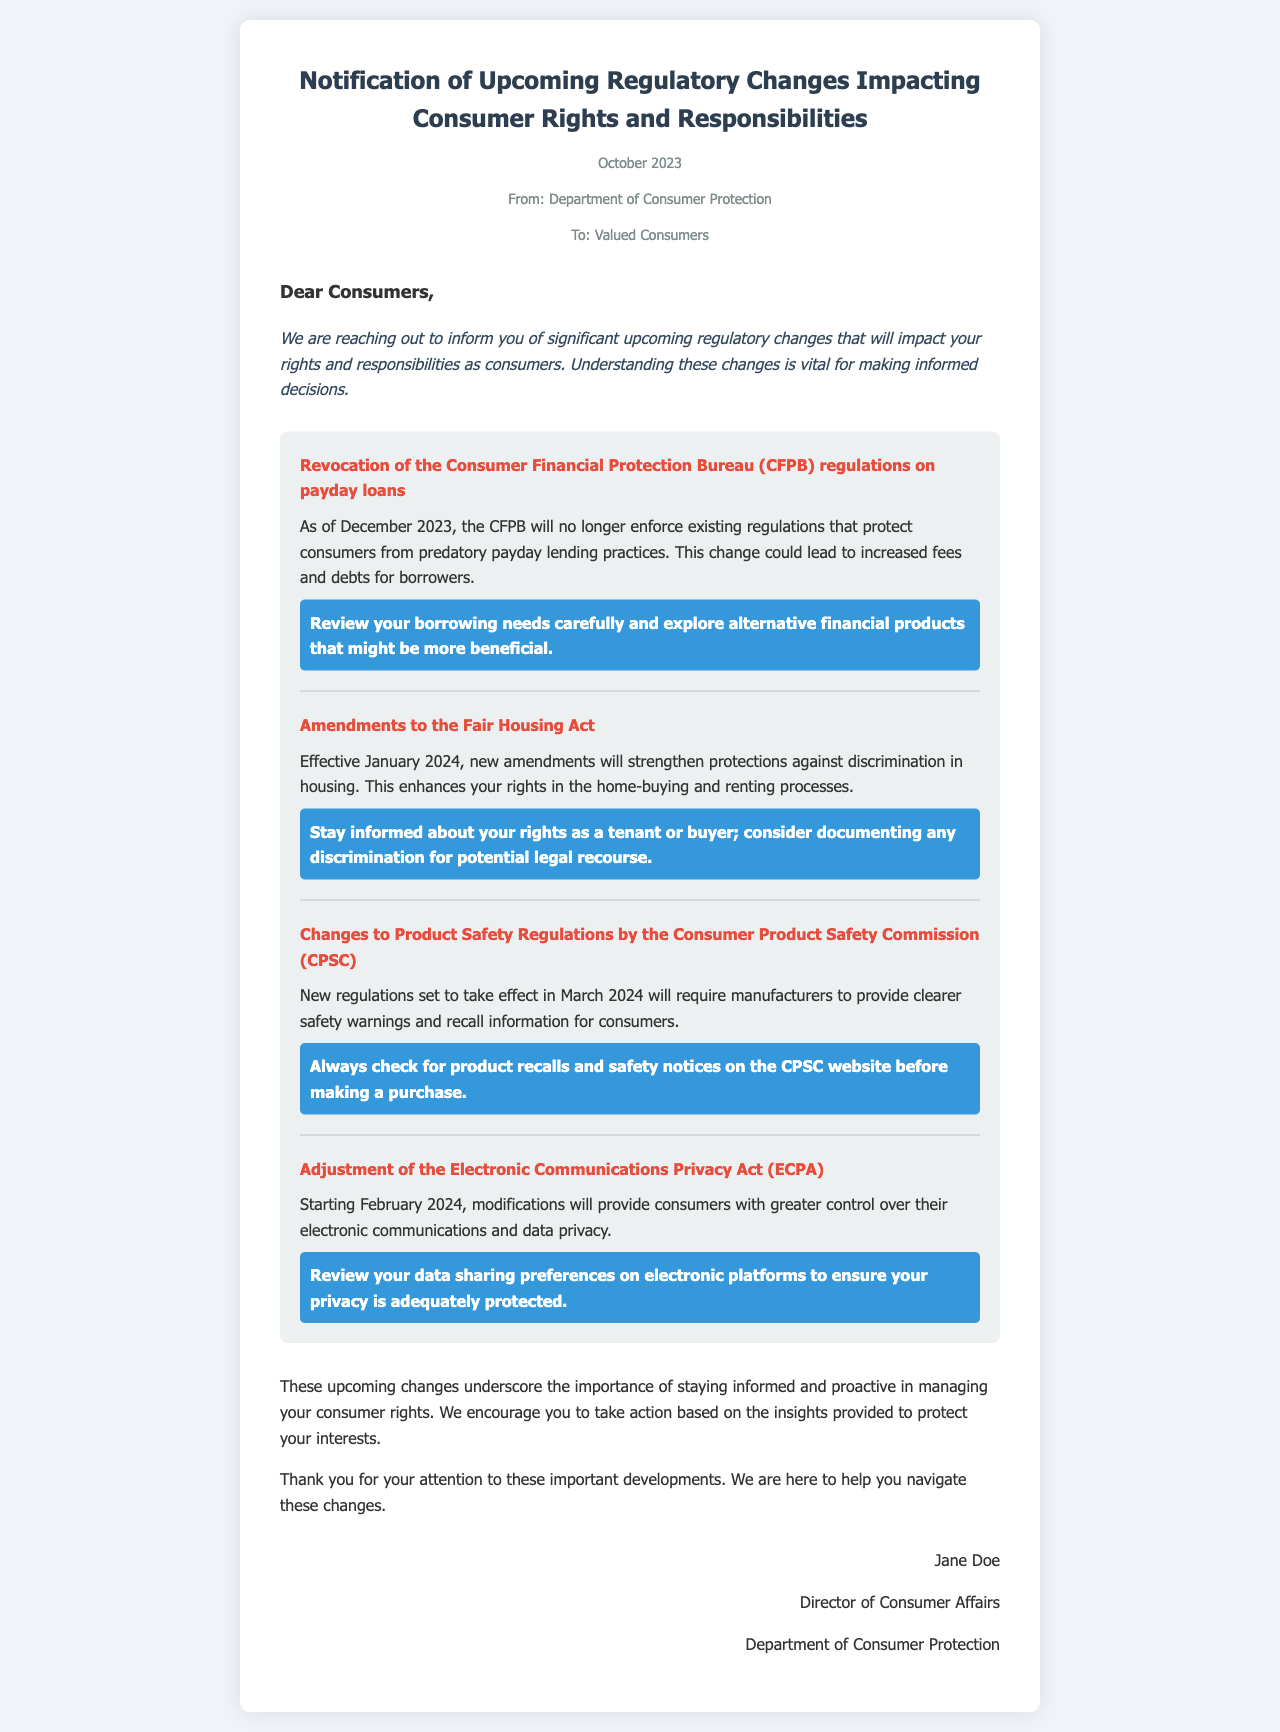What is the date of the notification? The notification is dated October 2023, as mentioned in the document details.
Answer: October 2023 Who is the sender of the letter? The sender of the letter is identified in the document as the Department of Consumer Protection.
Answer: Department of Consumer Protection What regulation is being revoked as of December 2023? The regulation being revoked is the Consumer Financial Protection Bureau (CFPB) regulations on payday loans.
Answer: CFPB regulations on payday loans What is the effective date of the amendments to the Fair Housing Act? The effective date for the amendments to the Fair Housing Act is stated as January 2024 in the document.
Answer: January 2024 What must consumers do according to the actionable insight for payday loans? Consumers are advised to review their borrowing needs carefully and explore alternative financial products.
Answer: Review your borrowing needs carefully What do the new regulations by the CPSC require manufacturers to provide? The new regulations require manufacturers to provide clearer safety warnings and recall information.
Answer: Clearer safety warnings and recall information When will the changes to the Electronic Communications Privacy Act take effect? The changes to the Electronic Communications Privacy Act will take effect starting in February 2024.
Answer: February 2024 What is the role of Jane Doe as per the letter? Jane Doe is identified as the Director of Consumer Affairs in the document.
Answer: Director of Consumer Affairs What is the main purpose of the letter? The main purpose of the letter is to inform consumers about significant upcoming regulatory changes impacting their rights and responsibilities.
Answer: Inform consumers about significant upcoming regulatory changes 